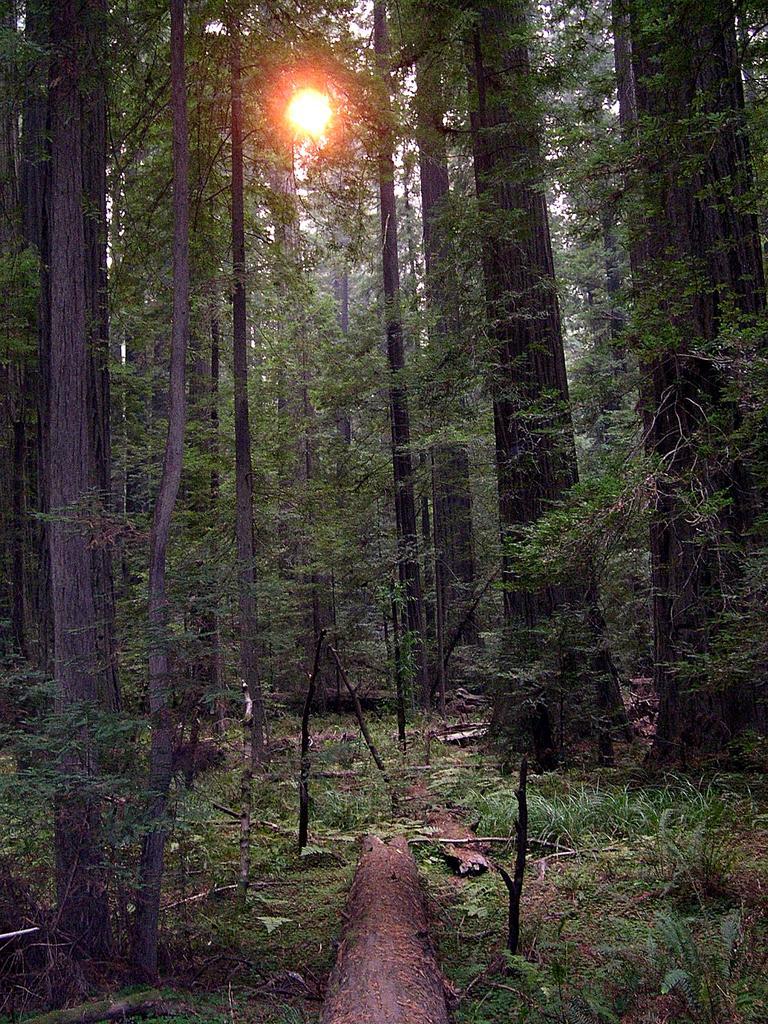Can you describe this image briefly? In this image we can see some trees, plants and wood on the ground, in the background, we can see the sunlight and the sky. 